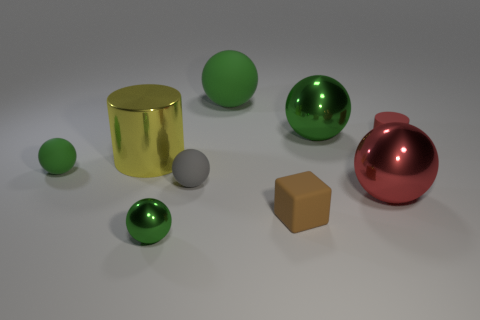Subtract all blue cylinders. How many green spheres are left? 4 Subtract 3 balls. How many balls are left? 3 Subtract all red spheres. How many spheres are left? 5 Subtract all tiny green spheres. How many spheres are left? 4 Subtract all red balls. Subtract all green blocks. How many balls are left? 5 Add 1 small matte balls. How many objects exist? 10 Subtract all cylinders. How many objects are left? 7 Subtract all large metal cylinders. Subtract all small matte cubes. How many objects are left? 7 Add 2 large yellow metal things. How many large yellow metal things are left? 3 Add 2 purple objects. How many purple objects exist? 2 